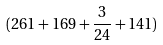<formula> <loc_0><loc_0><loc_500><loc_500>( 2 6 1 + 1 6 9 + \frac { 3 } { 2 4 } + 1 4 1 )</formula> 